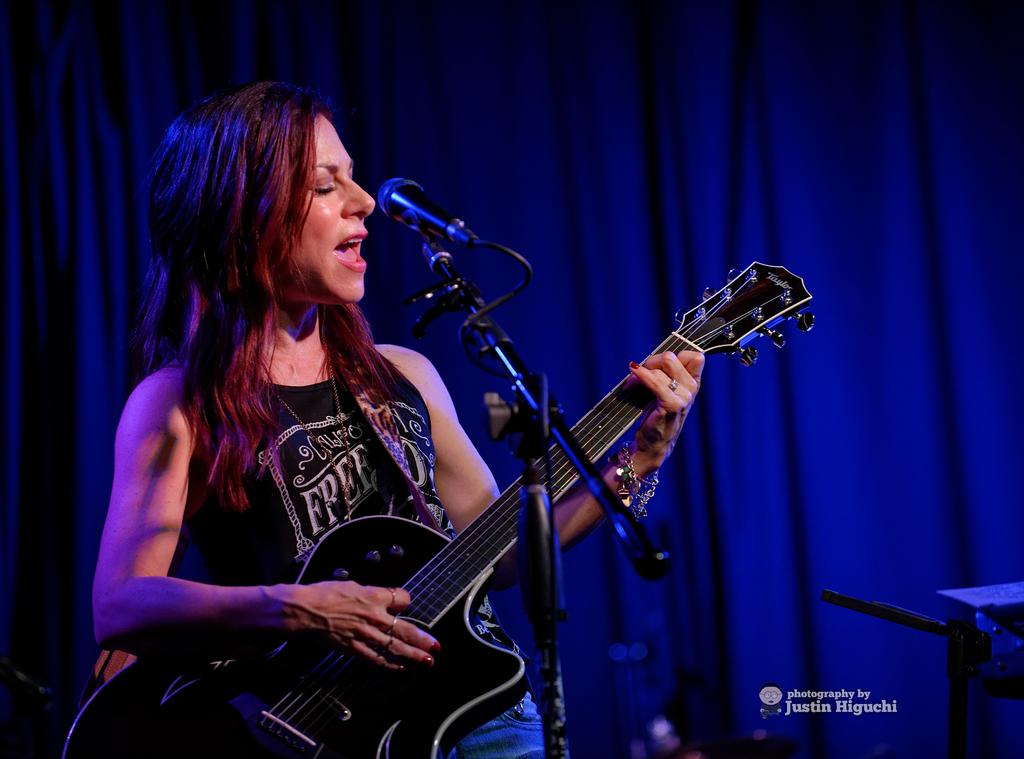What is the woman in the image doing? The woman is playing a guitar and singing in the image. How is the woman's voice being amplified? The woman is using a microphone in the image. What can be seen in the background of the image? There are curtains visible in the image. What type of yarn is the woman using to play the guitar in the image? There is no yarn present in the image; the woman is playing a guitar with her hands. 